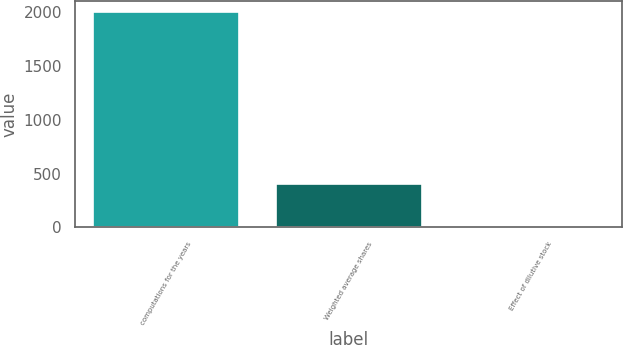<chart> <loc_0><loc_0><loc_500><loc_500><bar_chart><fcel>computations for the years<fcel>Weighted average shares<fcel>Effect of dilutive stock<nl><fcel>2002<fcel>402.24<fcel>2.3<nl></chart> 